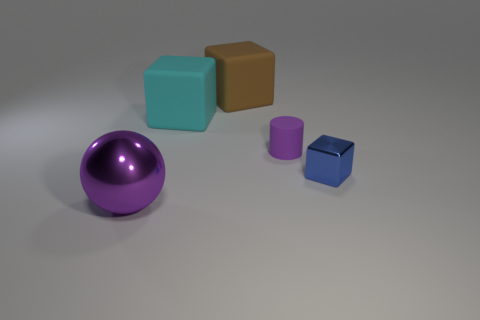Add 5 metallic objects. How many objects exist? 10 Subtract all balls. How many objects are left? 4 Add 4 cyan metallic spheres. How many cyan metallic spheres exist? 4 Subtract 0 blue cylinders. How many objects are left? 5 Subtract all blocks. Subtract all small blue shiny blocks. How many objects are left? 1 Add 2 cyan blocks. How many cyan blocks are left? 3 